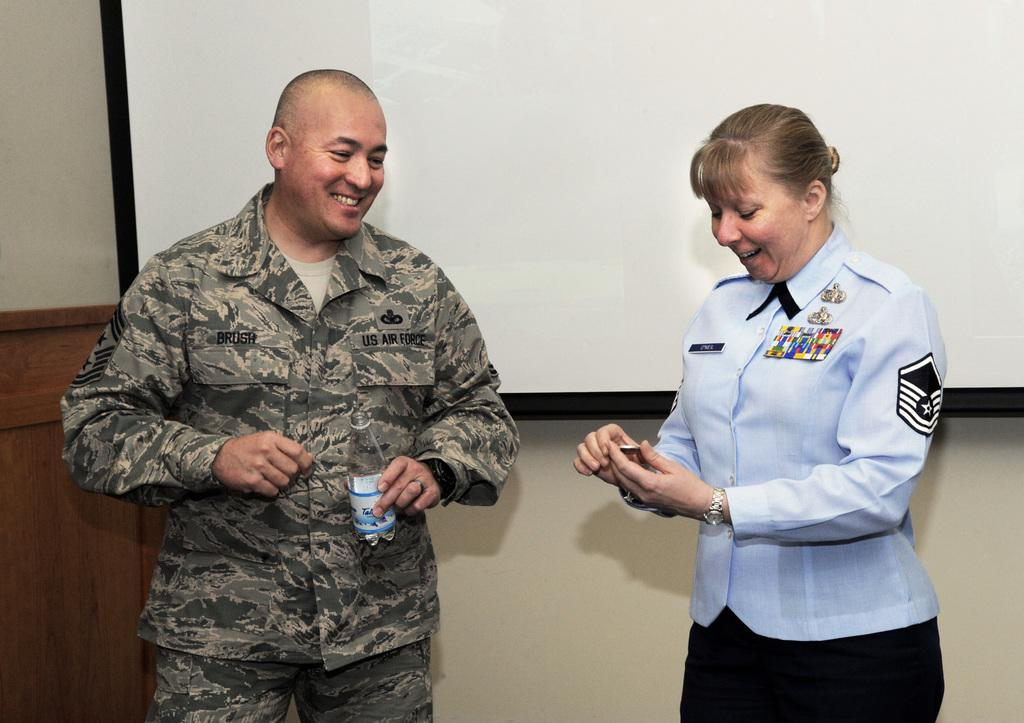How many people are in the image? There are two people in the image, a man and a woman. What is the man holding in the image? The man is holding a bottle. What expressions do the man and woman have in the image? Both the man and the woman are smiling. What can be seen in the background of the image? There is a wall and a screen in the image. What type of silver pen can be seen in the man's hand in the image? There is no pen, silver or otherwise, visible in the man's hand in the image. Can you see a hill in the background of the image? There is no hill present in the background of the image. 